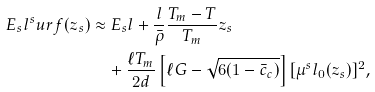Convert formula to latex. <formula><loc_0><loc_0><loc_500><loc_500>E _ { s } l ^ { s } u r f ( z _ { s } ) & \approx E _ { s } l + \frac { l } { \bar { \rho } } \frac { T _ { m } - T } { T _ { m } } z _ { s } \\ & \quad + \frac { \ell T _ { m } } { 2 d } \left [ \ell G - \sqrt { 6 ( 1 - \bar { c } _ { c } ) } \right ] [ \mu ^ { s } l _ { 0 } ( z _ { s } ) ] ^ { 2 } ,</formula> 